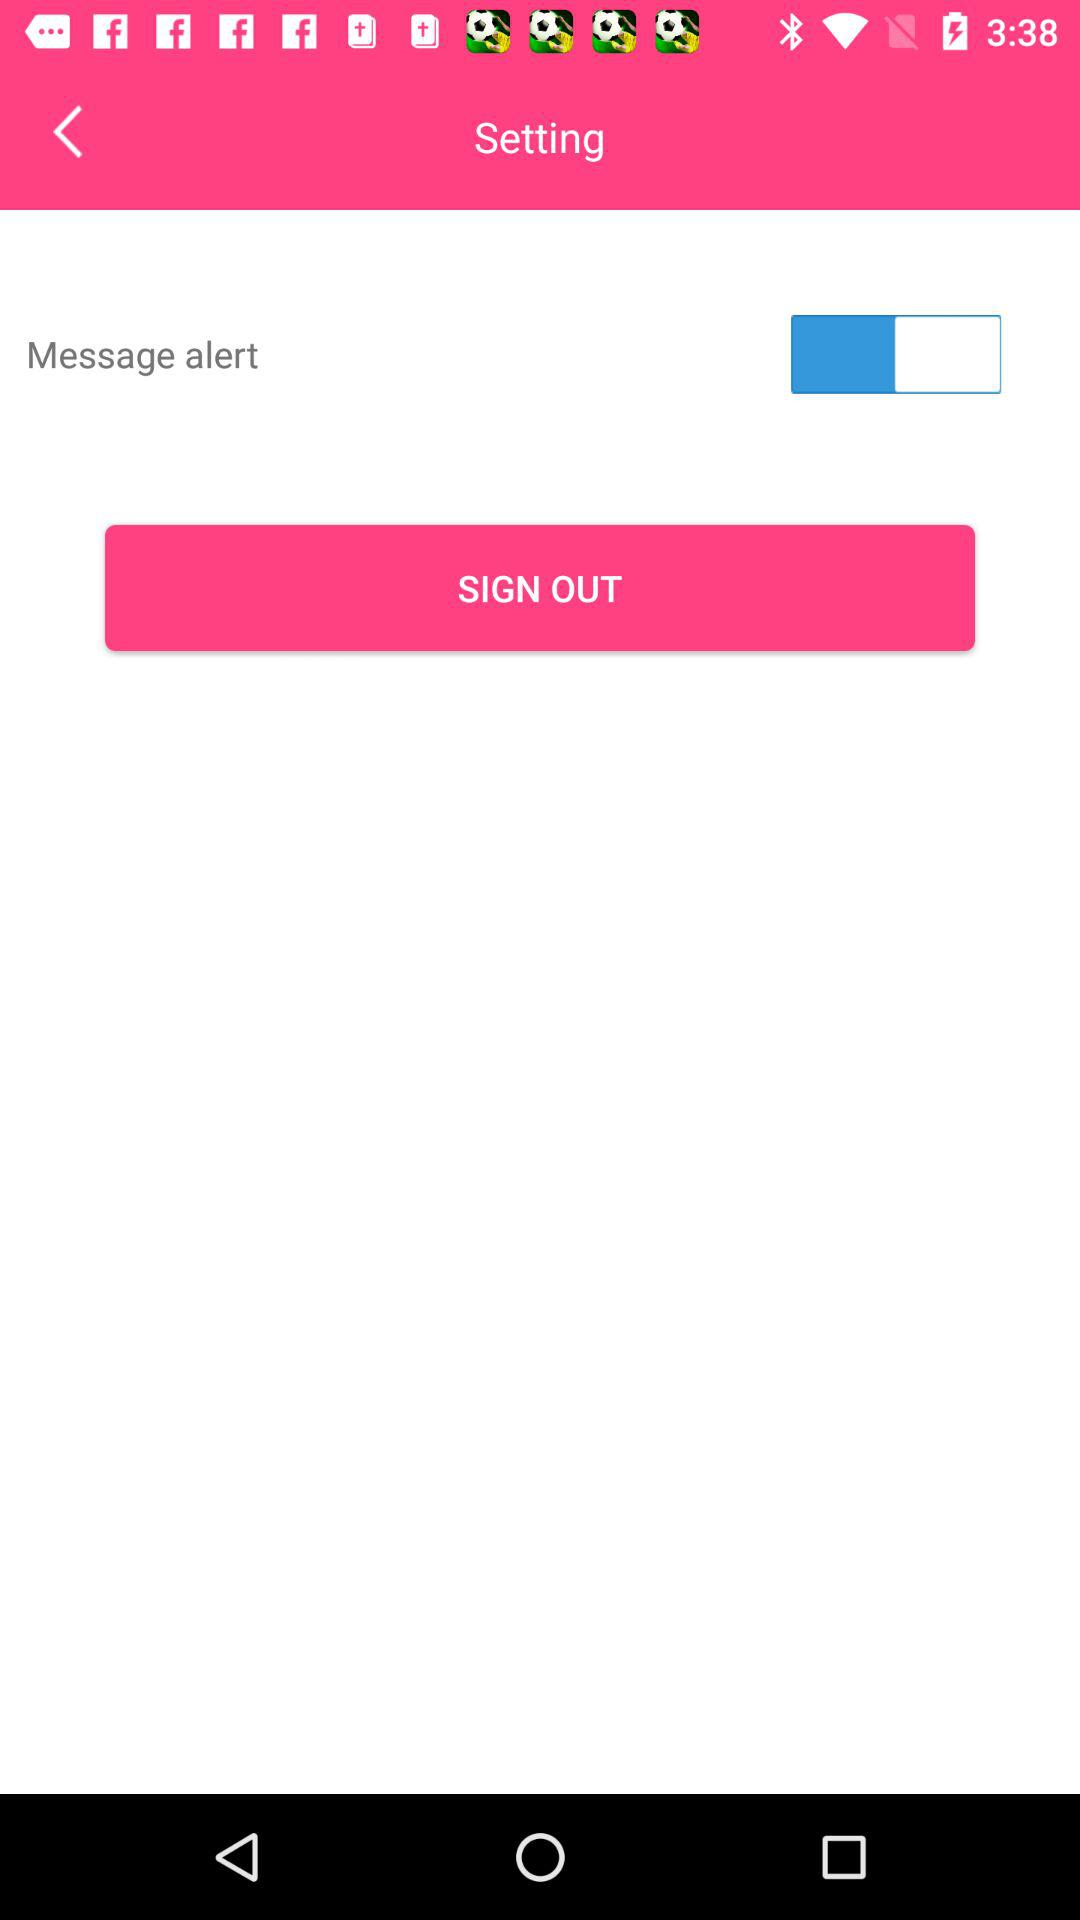What's the setting for "Message alert"? The setting is "on". 